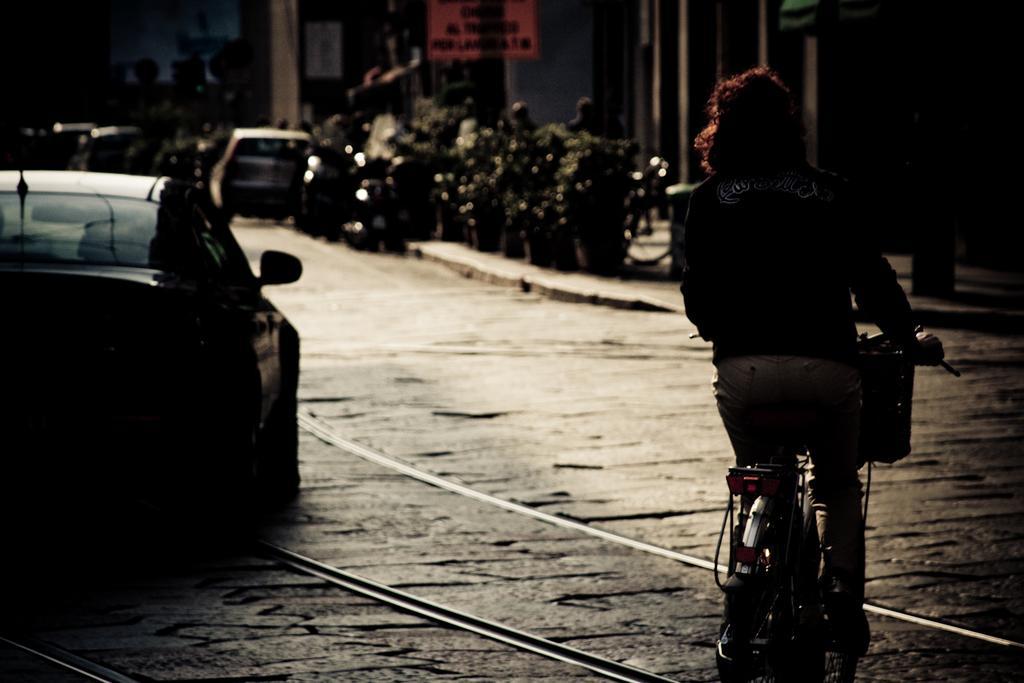In one or two sentences, can you explain what this image depicts? In the foreground of this image, there is a person cycling on the road. On the left, there is a car. In the background, there are plants, vehicles and the buildings. 